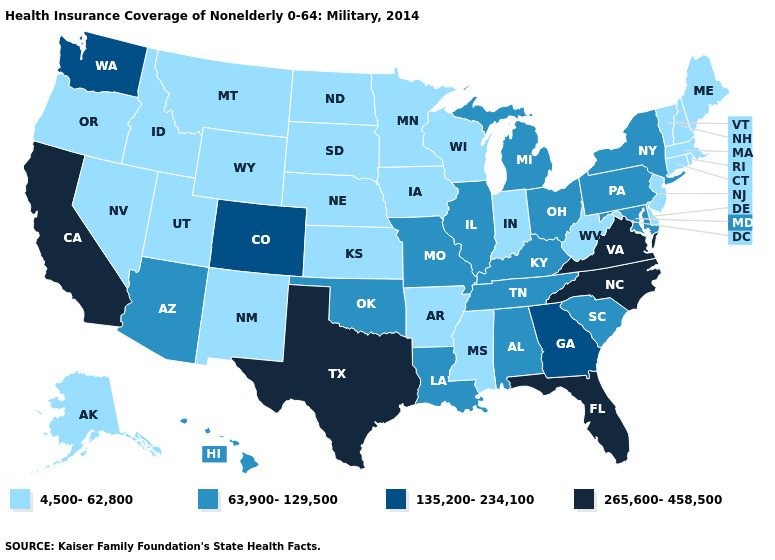Among the states that border Tennessee , which have the lowest value?
Write a very short answer. Arkansas, Mississippi. What is the value of New Hampshire?
Give a very brief answer. 4,500-62,800. What is the value of Oklahoma?
Keep it brief. 63,900-129,500. What is the lowest value in states that border Kentucky?
Short answer required. 4,500-62,800. Name the states that have a value in the range 63,900-129,500?
Write a very short answer. Alabama, Arizona, Hawaii, Illinois, Kentucky, Louisiana, Maryland, Michigan, Missouri, New York, Ohio, Oklahoma, Pennsylvania, South Carolina, Tennessee. Does the first symbol in the legend represent the smallest category?
Short answer required. Yes. Among the states that border Connecticut , does Rhode Island have the lowest value?
Short answer required. Yes. What is the highest value in the MidWest ?
Short answer required. 63,900-129,500. Does the map have missing data?
Be succinct. No. Name the states that have a value in the range 63,900-129,500?
Concise answer only. Alabama, Arizona, Hawaii, Illinois, Kentucky, Louisiana, Maryland, Michigan, Missouri, New York, Ohio, Oklahoma, Pennsylvania, South Carolina, Tennessee. Does Iowa have the same value as Indiana?
Give a very brief answer. Yes. Does the first symbol in the legend represent the smallest category?
Quick response, please. Yes. What is the value of Michigan?
Keep it brief. 63,900-129,500. What is the value of Louisiana?
Answer briefly. 63,900-129,500. Does North Carolina have the highest value in the South?
Concise answer only. Yes. 